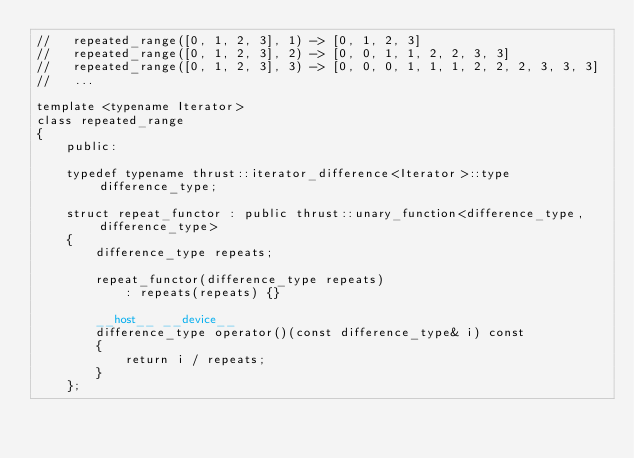Convert code to text. <code><loc_0><loc_0><loc_500><loc_500><_Cuda_>//   repeated_range([0, 1, 2, 3], 1) -> [0, 1, 2, 3] 
//   repeated_range([0, 1, 2, 3], 2) -> [0, 0, 1, 1, 2, 2, 3, 3]
//   repeated_range([0, 1, 2, 3], 3) -> [0, 0, 0, 1, 1, 1, 2, 2, 2, 3, 3, 3] 
//   ...

template <typename Iterator>
class repeated_range
{
    public:

    typedef typename thrust::iterator_difference<Iterator>::type difference_type;

    struct repeat_functor : public thrust::unary_function<difference_type,difference_type>
    {
        difference_type repeats;

        repeat_functor(difference_type repeats)
            : repeats(repeats) {}

        __host__ __device__
        difference_type operator()(const difference_type& i) const
        { 
            return i / repeats;
        }
    };
</code> 